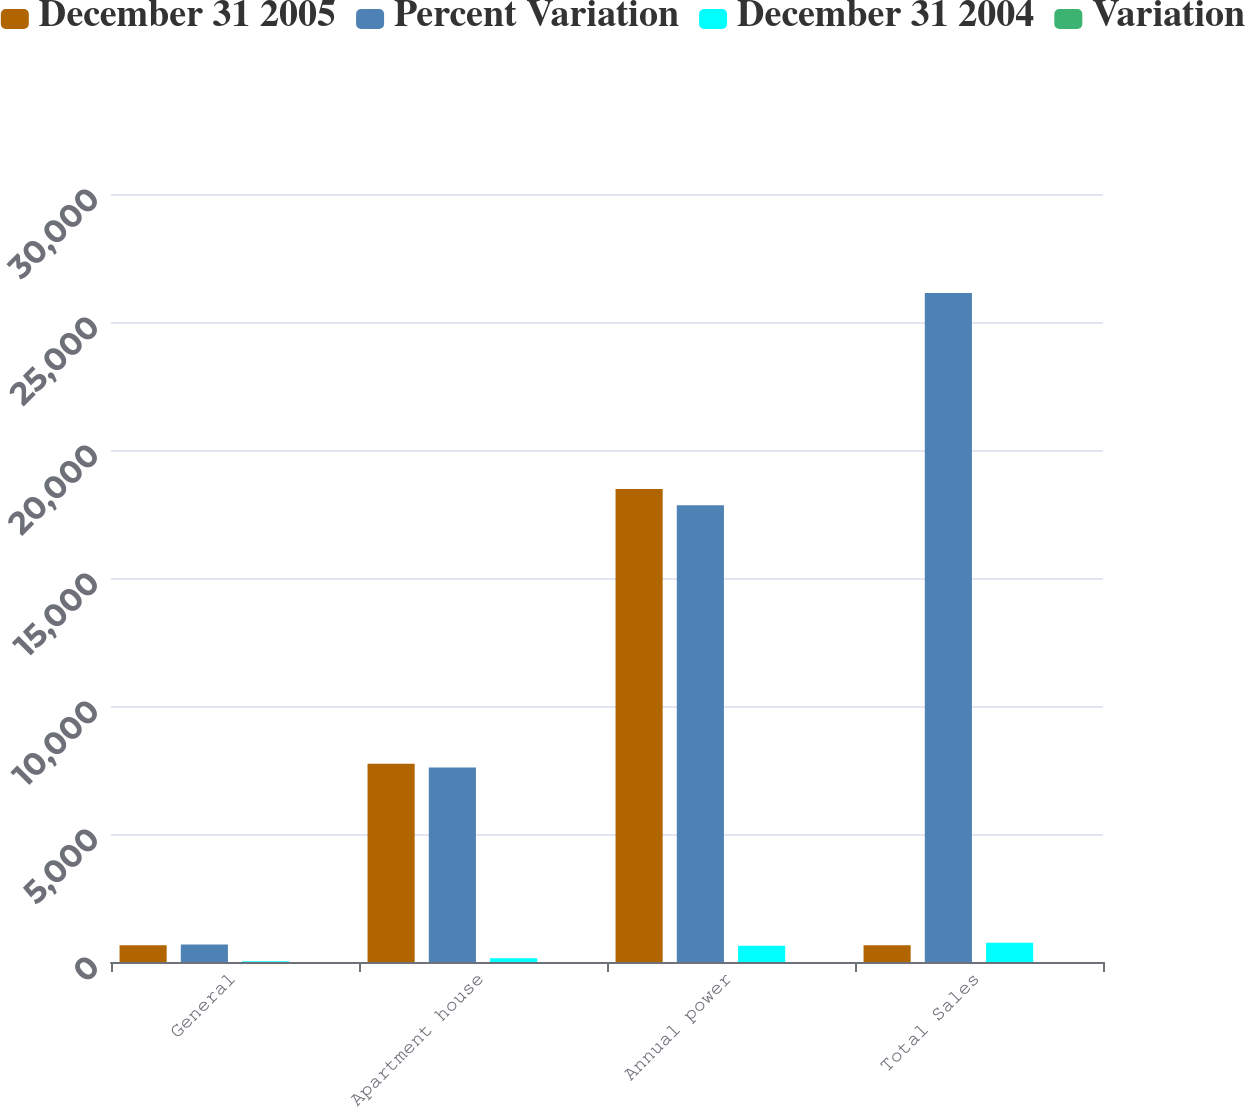Convert chart to OTSL. <chart><loc_0><loc_0><loc_500><loc_500><stacked_bar_chart><ecel><fcel>General<fcel>Apartment house<fcel>Annual power<fcel>Total Sales<nl><fcel>December 31 2005<fcel>655<fcel>7748<fcel>18474<fcel>655<nl><fcel>Percent Variation<fcel>685<fcel>7602<fcel>17842<fcel>26129<nl><fcel>December 31 2004<fcel>30<fcel>146<fcel>632<fcel>748<nl><fcel>Variation<fcel>4.4<fcel>1.9<fcel>3.5<fcel>2.9<nl></chart> 